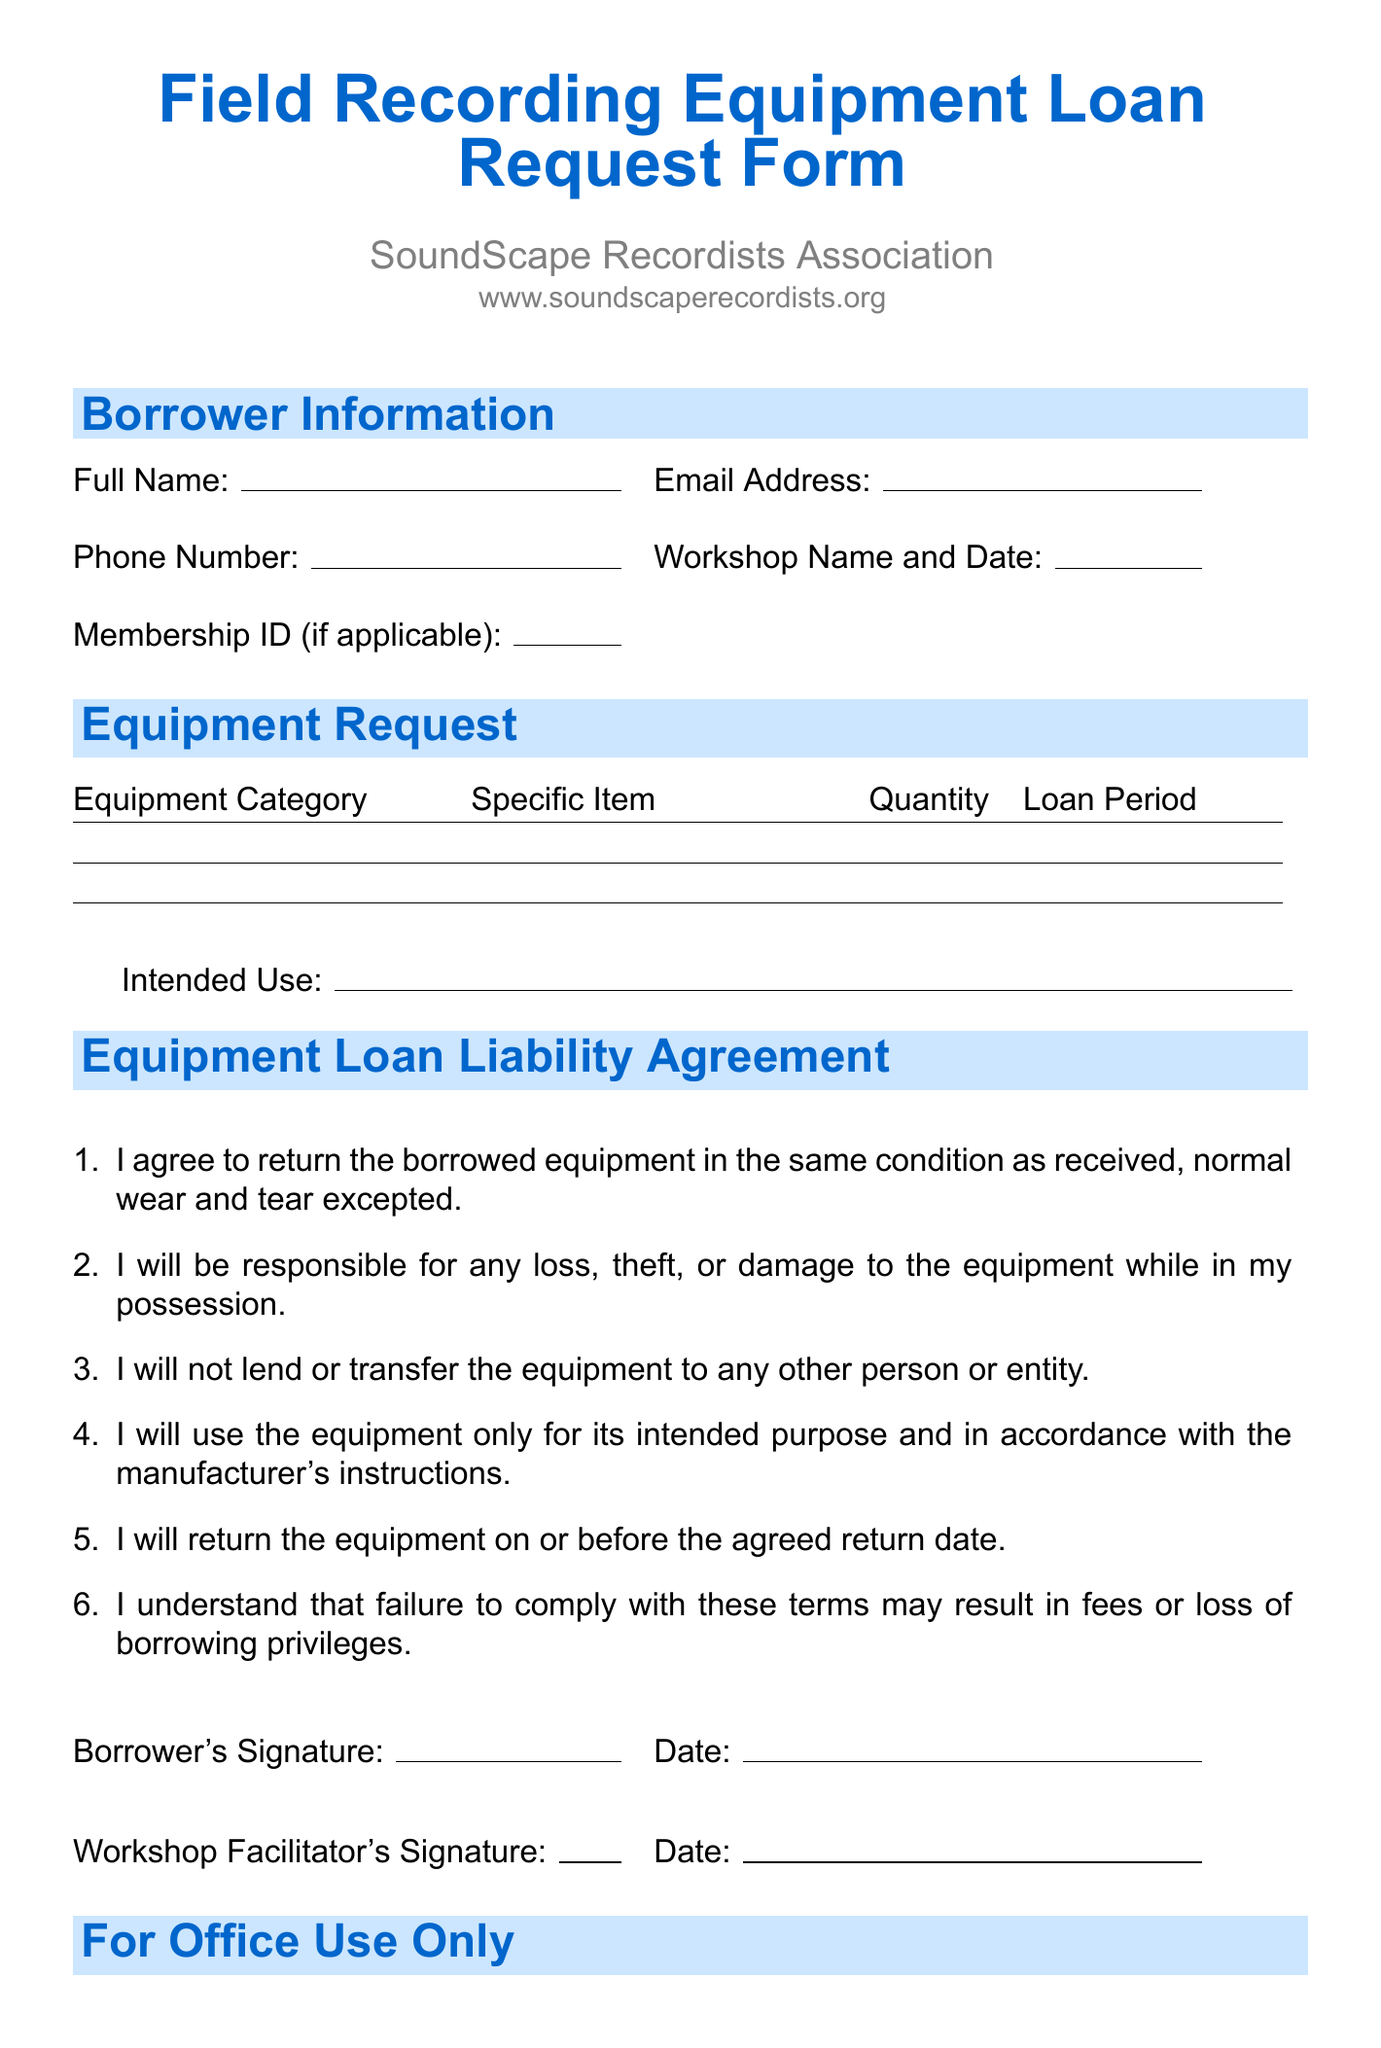what is the title of the form? The title of the form is mentioned at the top of the document.
Answer: Field Recording Equipment Loan Request Form who is the organization behind the form? The organization name is listed below the form title.
Answer: SoundScape Recordists Association how many equipment categories are listed? The number of equipment categories can be counted in the document.
Answer: 5 name one item available under Microphones. The document lists specific items under the Microphones category.
Answer: Sennheiser MKH 416 Shotgun Microphone what does the borrower agree to in Clause 1 of the liability agreement? The first clause describes the borrower's responsibility regarding the condition of the equipment.
Answer: return the borrowed equipment in the same condition as received how many signature fields are required on the form? The number of signature fields is detailed in the signature section of the document.
Answer: 4 what must be included under the Equipment Request section? The document specifies multiple fields within the Equipment Request section.
Answer: Equipment Category, Specific Item, Quantity, Intended Use, Loan Period what is required in the office use section? The office use section consists of specific information that staff must fill out.
Answer: Equipment Condition at Checkout, Equipment Condition at Return, Late Return Fees, Damage Fees, Processed by 